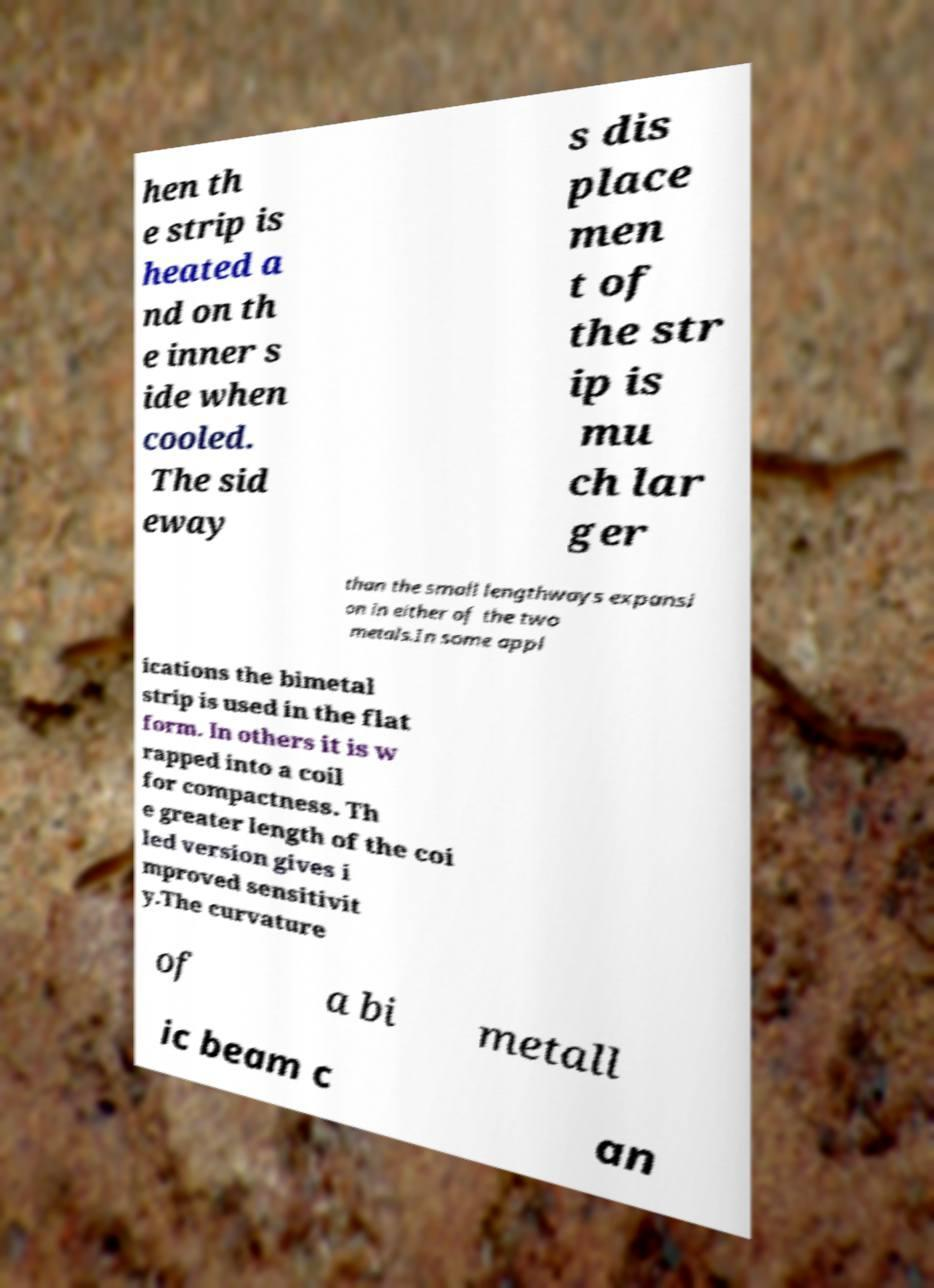Please read and relay the text visible in this image. What does it say? hen th e strip is heated a nd on th e inner s ide when cooled. The sid eway s dis place men t of the str ip is mu ch lar ger than the small lengthways expansi on in either of the two metals.In some appl ications the bimetal strip is used in the flat form. In others it is w rapped into a coil for compactness. Th e greater length of the coi led version gives i mproved sensitivit y.The curvature of a bi metall ic beam c an 